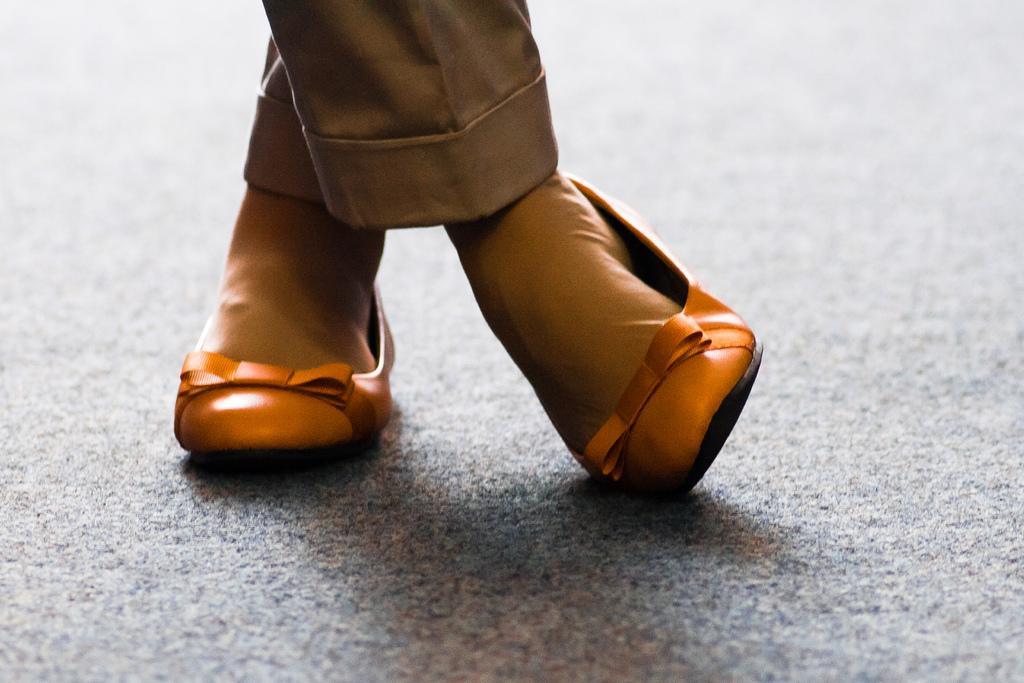Could you give a brief overview of what you see in this image? In this image I can see the person wearing the brown color dress and also shoes. The person is standing on the ash color surface. 